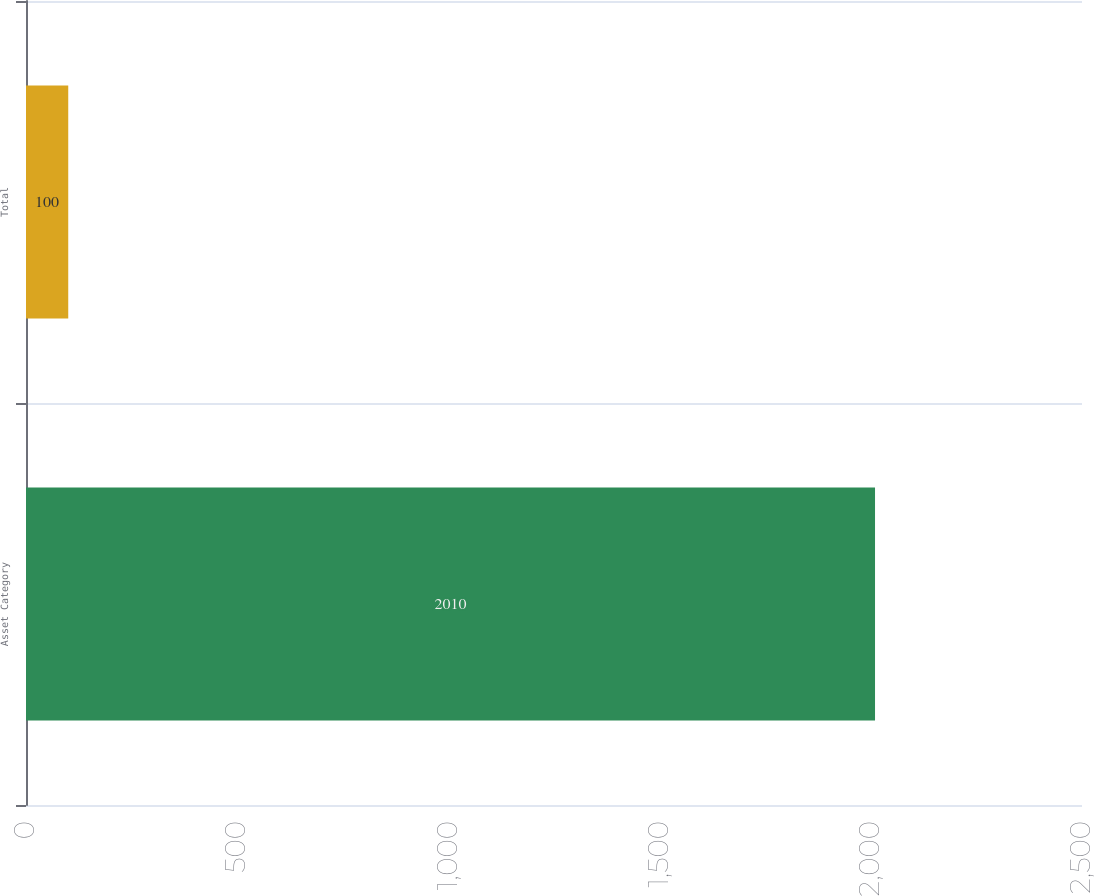Convert chart to OTSL. <chart><loc_0><loc_0><loc_500><loc_500><bar_chart><fcel>Asset Category<fcel>Total<nl><fcel>2010<fcel>100<nl></chart> 